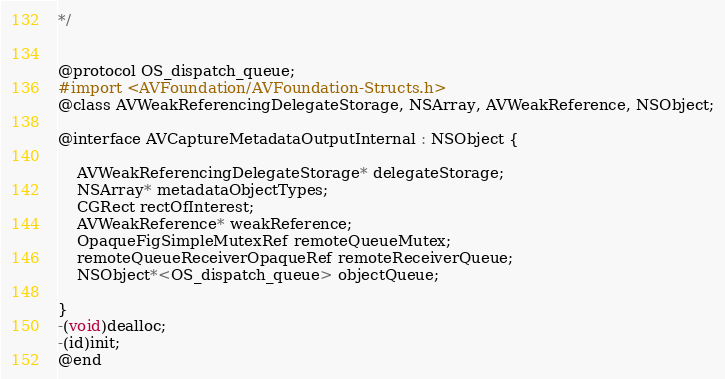<code> <loc_0><loc_0><loc_500><loc_500><_C_>*/


@protocol OS_dispatch_queue;
#import <AVFoundation/AVFoundation-Structs.h>
@class AVWeakReferencingDelegateStorage, NSArray, AVWeakReference, NSObject;

@interface AVCaptureMetadataOutputInternal : NSObject {

	AVWeakReferencingDelegateStorage* delegateStorage;
	NSArray* metadataObjectTypes;
	CGRect rectOfInterest;
	AVWeakReference* weakReference;
	OpaqueFigSimpleMutexRef remoteQueueMutex;
	remoteQueueReceiverOpaqueRef remoteReceiverQueue;
	NSObject*<OS_dispatch_queue> objectQueue;

}
-(void)dealloc;
-(id)init;
@end

</code> 